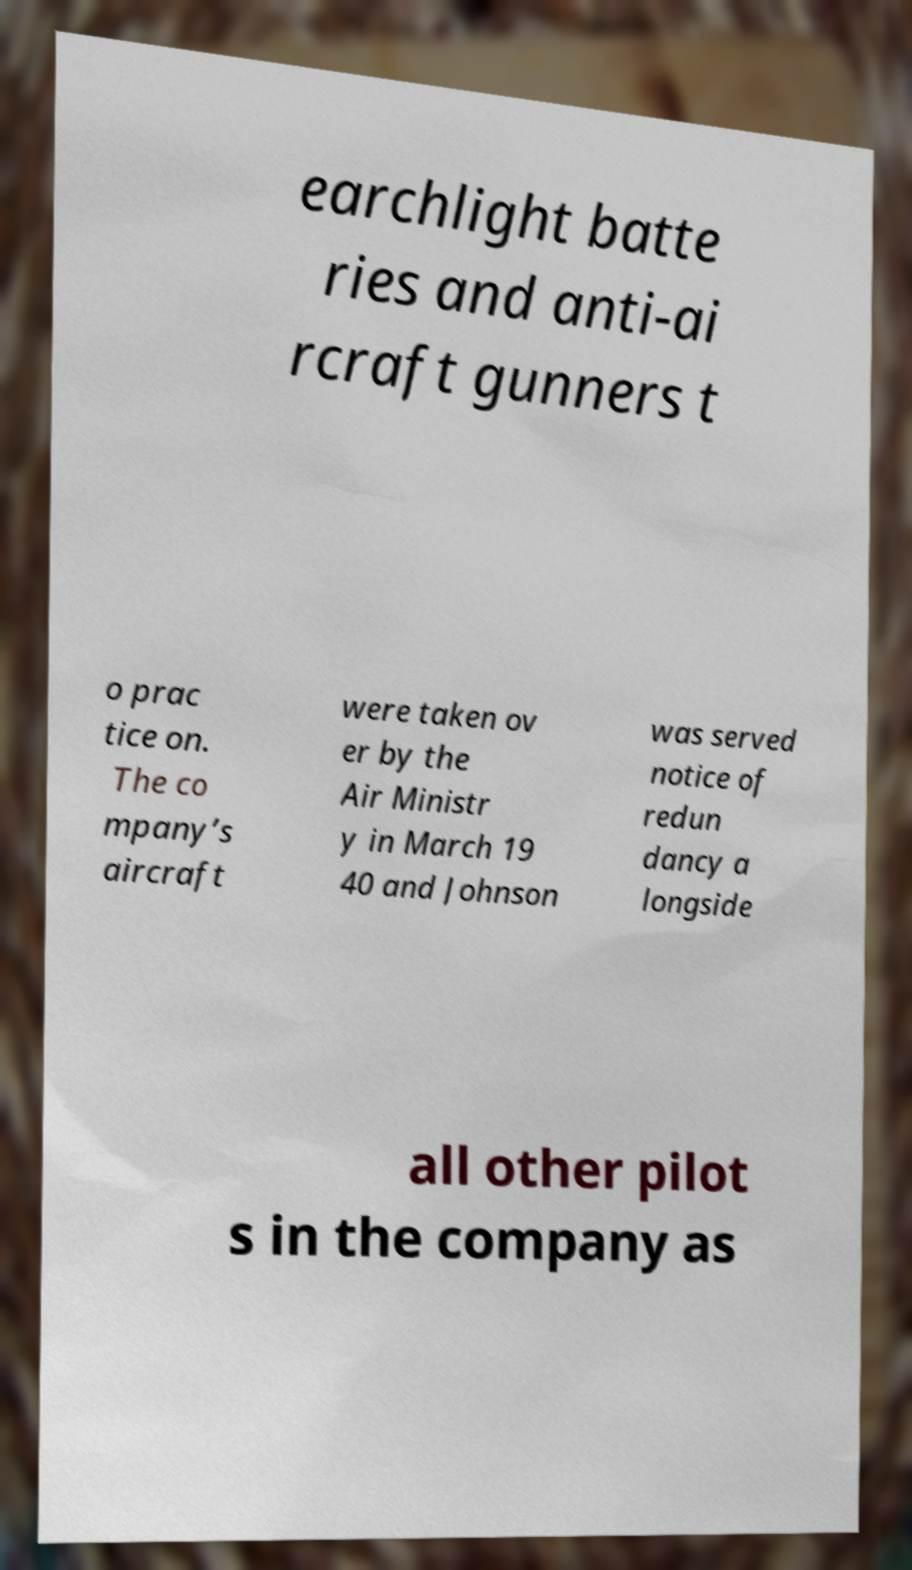Please identify and transcribe the text found in this image. earchlight batte ries and anti-ai rcraft gunners t o prac tice on. The co mpany’s aircraft were taken ov er by the Air Ministr y in March 19 40 and Johnson was served notice of redun dancy a longside all other pilot s in the company as 